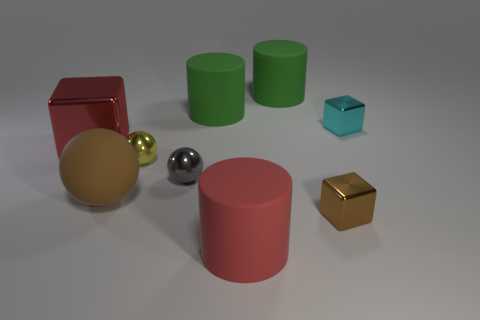Subtract all cubes. How many objects are left? 6 Add 7 small brown matte balls. How many small brown matte balls exist? 7 Subtract 1 red cylinders. How many objects are left? 8 Subtract all big rubber objects. Subtract all large brown rubber spheres. How many objects are left? 4 Add 9 gray objects. How many gray objects are left? 10 